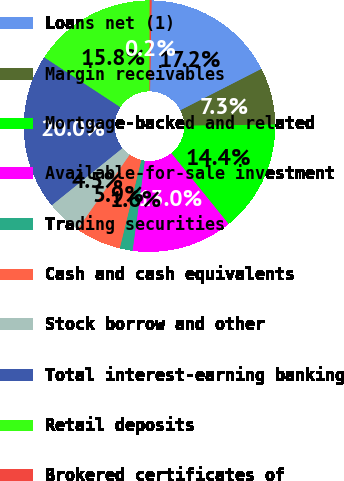Convert chart to OTSL. <chart><loc_0><loc_0><loc_500><loc_500><pie_chart><fcel>Loans net (1)<fcel>Margin receivables<fcel>Mortgage-backed and related<fcel>Available-for-sale investment<fcel>Trading securities<fcel>Cash and cash equivalents<fcel>Stock borrow and other<fcel>Total interest-earning banking<fcel>Retail deposits<fcel>Brokered certificates of<nl><fcel>17.22%<fcel>7.31%<fcel>14.39%<fcel>12.97%<fcel>1.65%<fcel>5.9%<fcel>4.48%<fcel>20.05%<fcel>15.8%<fcel>0.24%<nl></chart> 